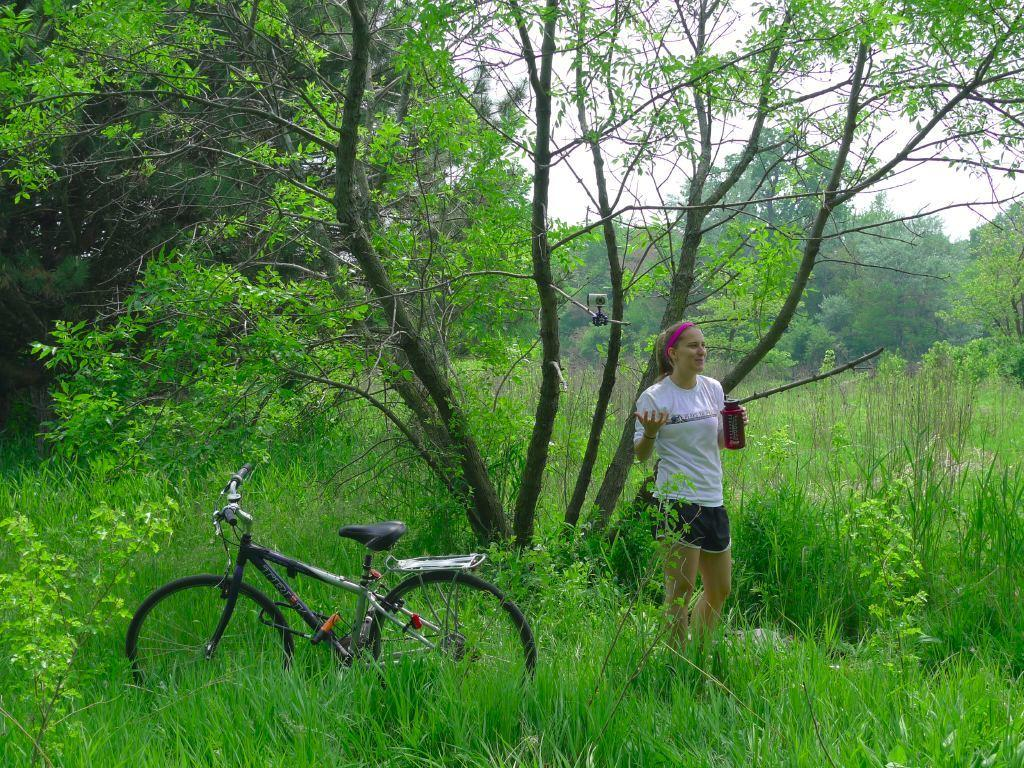What is the main subject in the foreground of the image? There is a woman in the foreground of the image. What is the woman standing on? The woman is standing on the grass. What is the woman holding in her hand? The woman is holding a bottle. What other object is present in the foreground of the image? There is a bicycle in the foreground. What can be seen in the background of the image? There are trees, grass, plants, and the sky visible in the background of the image. What type of finger can be seen pulling the bicycle in the image? There is no finger pulling the bicycle in the image; the bicycle is stationary. What type of shirt is the woman wearing in the image? The provided facts do not mention the type of shirt the woman is wearing, so we cannot determine that information from the image. 